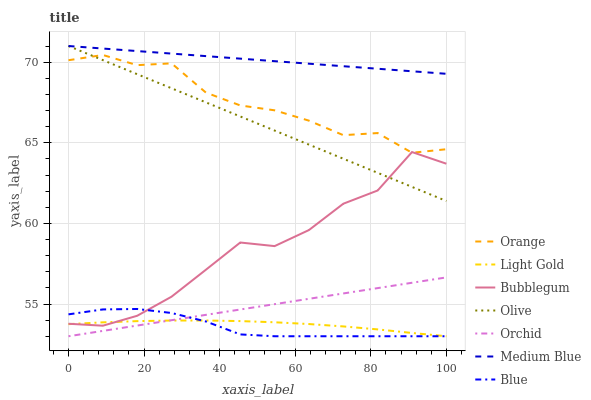Does Blue have the minimum area under the curve?
Answer yes or no. Yes. Does Medium Blue have the maximum area under the curve?
Answer yes or no. Yes. Does Bubblegum have the minimum area under the curve?
Answer yes or no. No. Does Bubblegum have the maximum area under the curve?
Answer yes or no. No. Is Orchid the smoothest?
Answer yes or no. Yes. Is Bubblegum the roughest?
Answer yes or no. Yes. Is Medium Blue the smoothest?
Answer yes or no. No. Is Medium Blue the roughest?
Answer yes or no. No. Does Blue have the lowest value?
Answer yes or no. Yes. Does Bubblegum have the lowest value?
Answer yes or no. No. Does Olive have the highest value?
Answer yes or no. Yes. Does Bubblegum have the highest value?
Answer yes or no. No. Is Light Gold less than Orange?
Answer yes or no. Yes. Is Olive greater than Blue?
Answer yes or no. Yes. Does Blue intersect Light Gold?
Answer yes or no. Yes. Is Blue less than Light Gold?
Answer yes or no. No. Is Blue greater than Light Gold?
Answer yes or no. No. Does Light Gold intersect Orange?
Answer yes or no. No. 